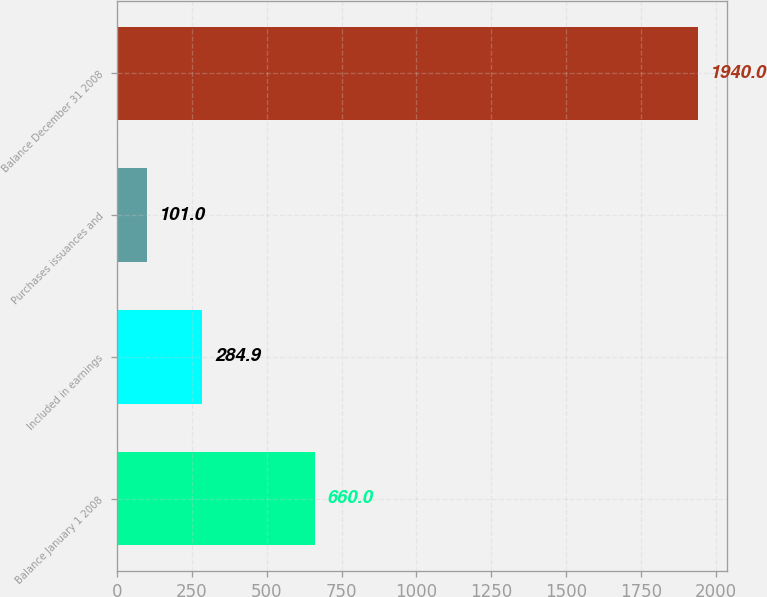Convert chart to OTSL. <chart><loc_0><loc_0><loc_500><loc_500><bar_chart><fcel>Balance January 1 2008<fcel>Included in earnings<fcel>Purchases issuances and<fcel>Balance December 31 2008<nl><fcel>660<fcel>284.9<fcel>101<fcel>1940<nl></chart> 